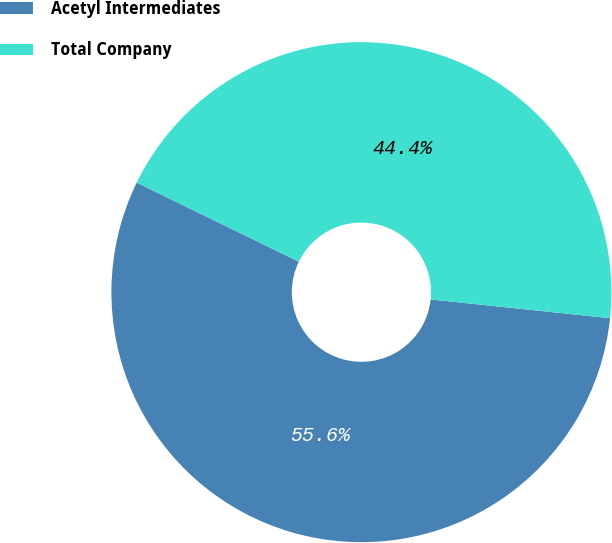Convert chart to OTSL. <chart><loc_0><loc_0><loc_500><loc_500><pie_chart><fcel>Acetyl Intermediates<fcel>Total Company<nl><fcel>55.56%<fcel>44.44%<nl></chart> 